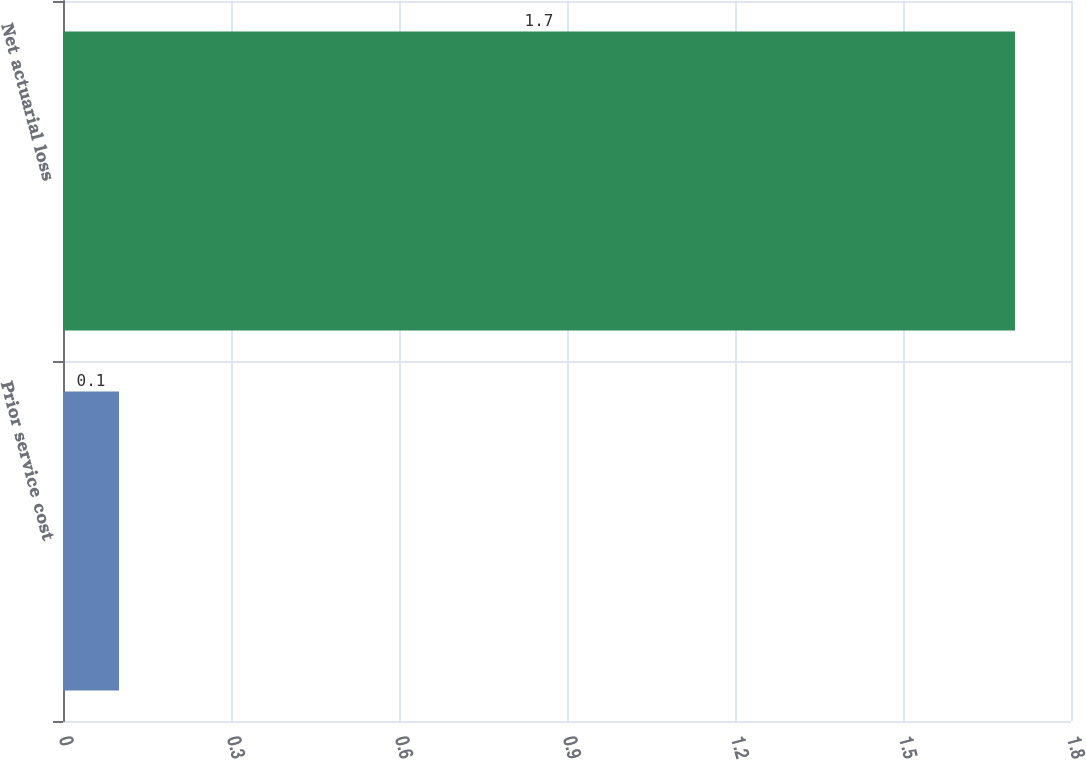Convert chart to OTSL. <chart><loc_0><loc_0><loc_500><loc_500><bar_chart><fcel>Prior service cost<fcel>Net actuarial loss<nl><fcel>0.1<fcel>1.7<nl></chart> 